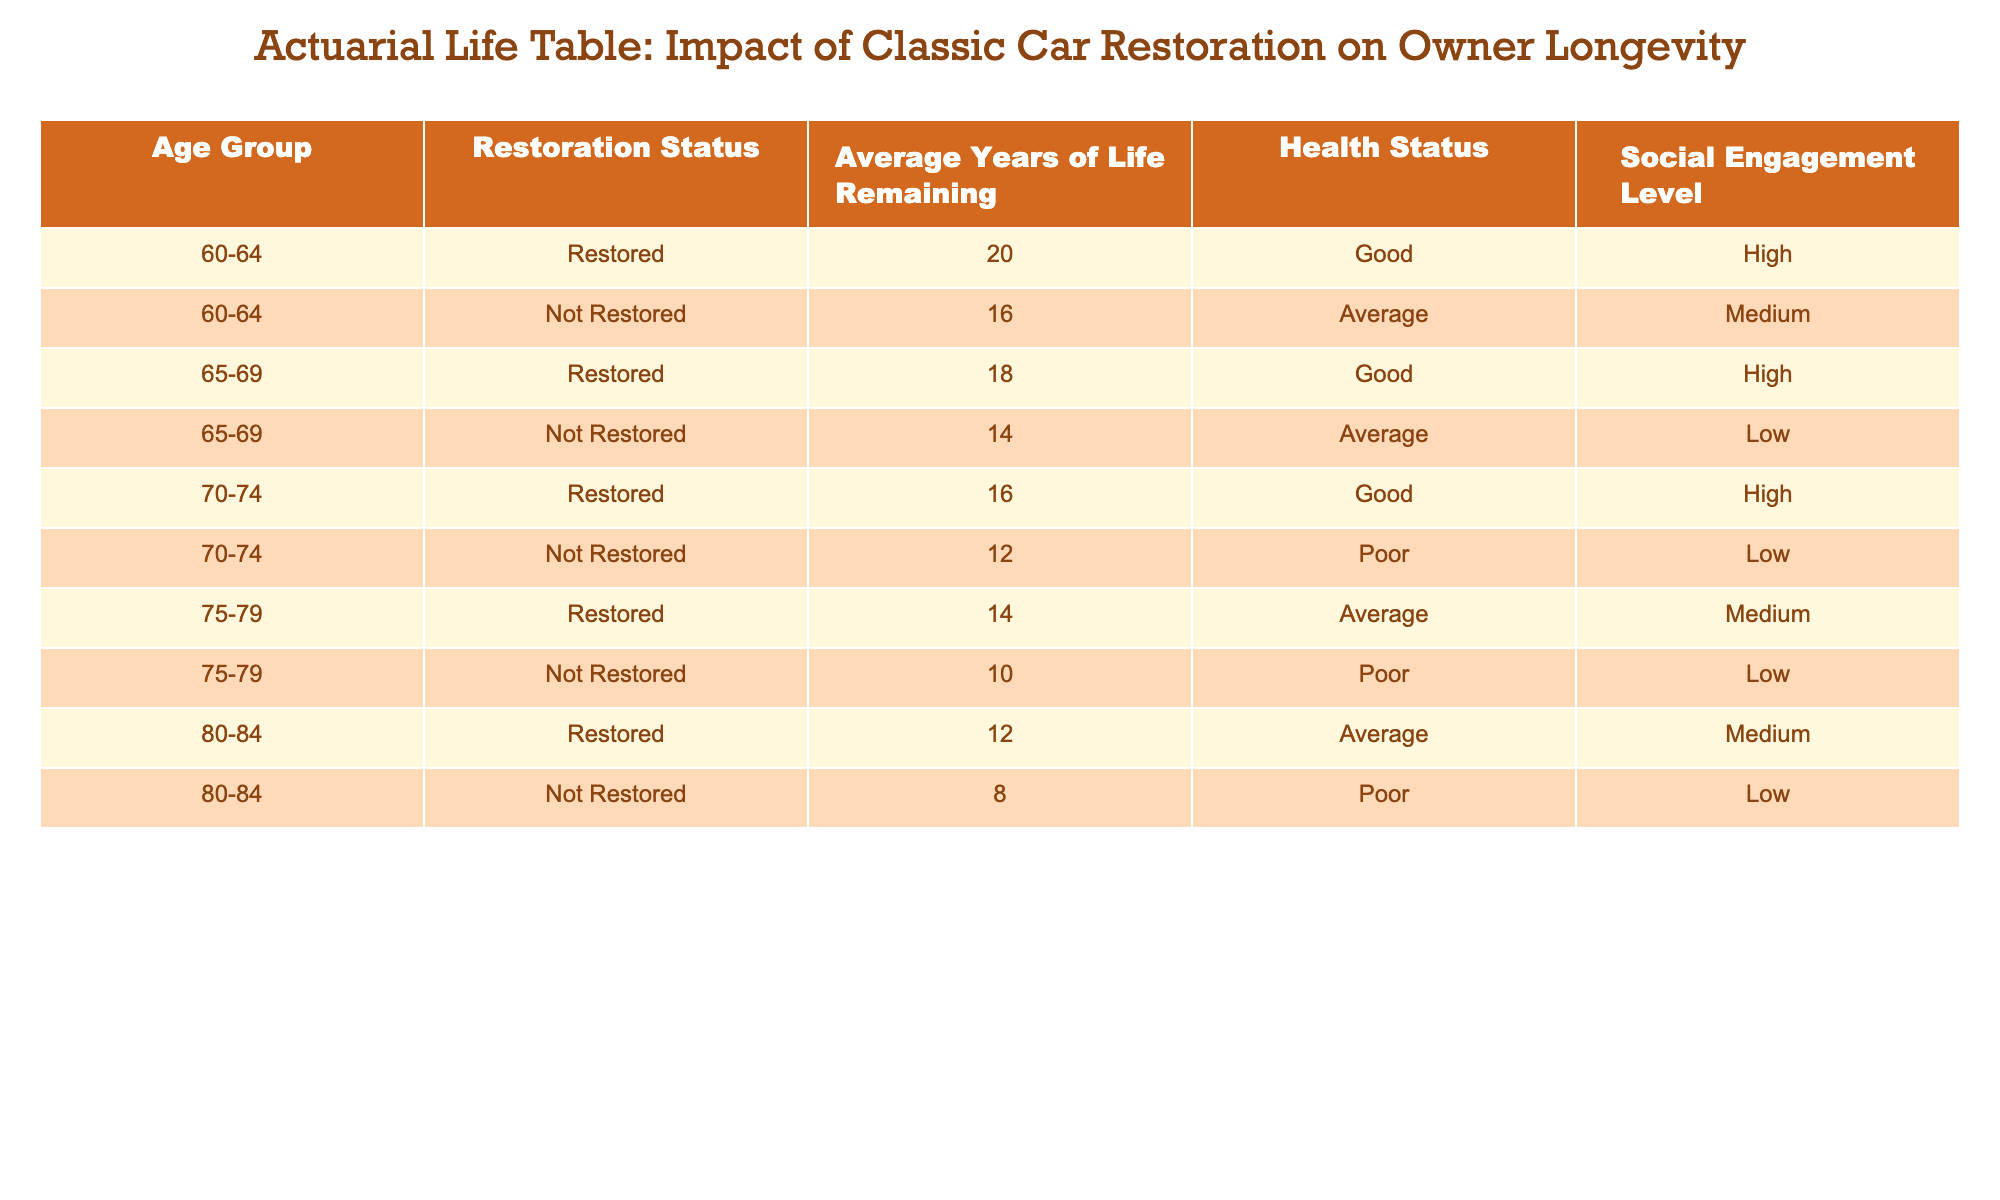What is the average years of life remaining for those aged 60-64 who have restored their cars? In the table, the only entry for the age group 60-64 with a restoration status of "Restored" shows an average of 20 years of life remaining. As there's only one data point, the average remains 20 years.
Answer: 20 What is the difference in average years of life remaining between restored and not restored cars for those aged 70-74? For the age group 70-74, the restored average is 16 years, and the not restored average is 12 years. The difference is 16 - 12 = 4 years.
Answer: 4 Is the health status for restored cars in the age group 80-84 good? The table indicates that for the age group 80-84, the health status for those with restored cars is "Average". Thus, it is not "Good".
Answer: No Which age group has the highest average years of life remaining for restored cars? Reviewing the restored averages, the age group 60-64 has an average of 20 years (the highest) while 65-69 has 18 years. Hence, 60-64 has the highest.
Answer: 60-64 What is the total average years of life remaining for all age groups with restored cars? We sum the average years remaining for restored cars: 20 (60-64) + 18 (65-69) + 16 (70-74) + 14 (75-79) + 12 (80-84) = 20 + 18 + 16 + 14 + 12 = 80 years.
Answer: 80 Does every age group have a higher average years of life remaining for restored cars compared to not restored cars? Compare the average years remaining: for age group 60-64, restored (20) > not restored (16); for 65-69, restored (18) > not restored (14); for 70-74, restored (16) > not restored (12); but for 75-79, restored (14) > not restored (10); and for 80-84, restored (12) > not restored (8). Thus, yes, all meet this condition.
Answer: Yes What is the average social engagement level for both restored and not restored classic cars in the age group 75-79? The average social engagement level for restored is "Medium" and for not restored is "Low". Combining these assessments, we can note a notable difference exists, but we cannot calculate a numeric average without quantitative values.
Answer: N/A How many age groups have a "Poor" health status for not restored cars? The age groups with "Poor" health status for not restored cars are 70-74 and 80-84, providing two groups with this status.
Answer: 2 Which age group has the lowest average life expectancy if their car is not restored? From the table, the age group 80-84 has the lowest average life remaining at 8 years for not restored cars compared to the others.
Answer: 80-84 